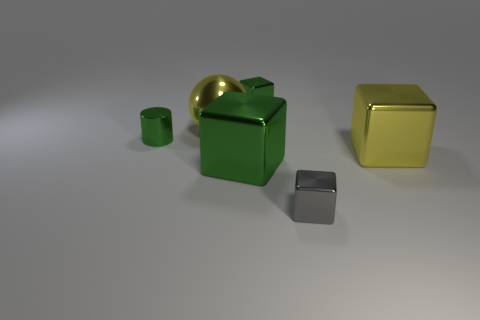Subtract all yellow cubes. How many cubes are left? 3 Add 2 objects. How many objects exist? 8 Subtract all cyan blocks. Subtract all gray spheres. How many blocks are left? 4 Subtract all cubes. How many objects are left? 2 Add 5 purple rubber blocks. How many purple rubber blocks exist? 5 Subtract 1 gray blocks. How many objects are left? 5 Subtract all big yellow matte spheres. Subtract all large yellow blocks. How many objects are left? 5 Add 4 shiny spheres. How many shiny spheres are left? 5 